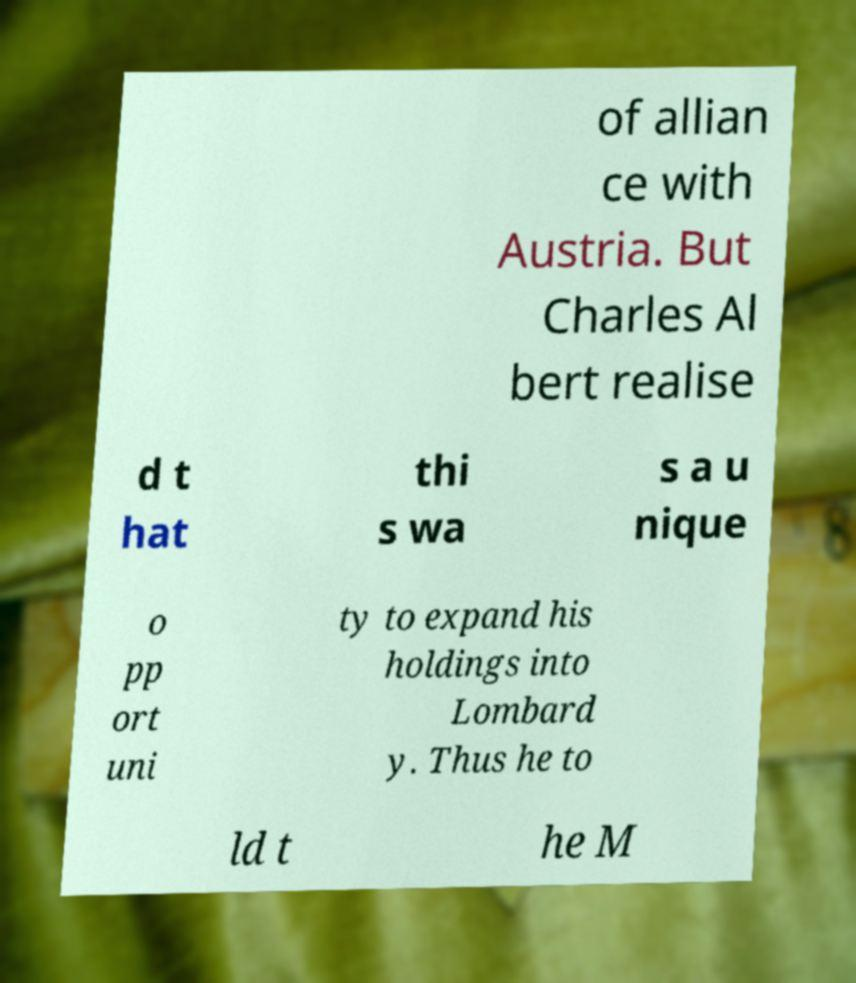For documentation purposes, I need the text within this image transcribed. Could you provide that? of allian ce with Austria. But Charles Al bert realise d t hat thi s wa s a u nique o pp ort uni ty to expand his holdings into Lombard y. Thus he to ld t he M 